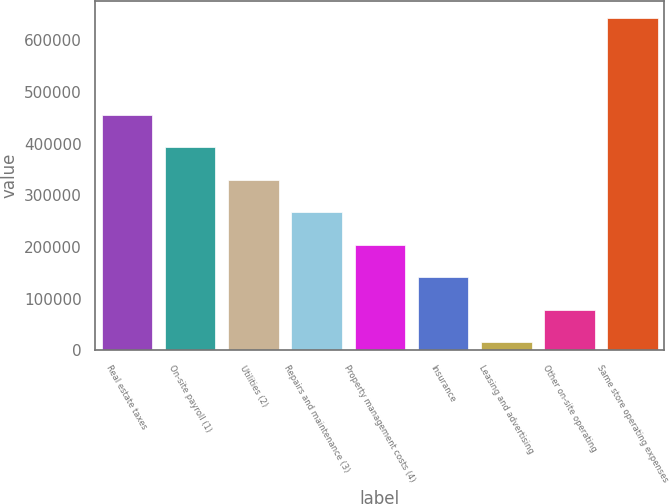Convert chart. <chart><loc_0><loc_0><loc_500><loc_500><bar_chart><fcel>Real estate taxes<fcel>On-site payroll (1)<fcel>Utilities (2)<fcel>Repairs and maintenance (3)<fcel>Property management costs (4)<fcel>Insurance<fcel>Leasing and advertising<fcel>Other on-site operating<fcel>Same store operating expenses<nl><fcel>455705<fcel>392842<fcel>329979<fcel>267116<fcel>204253<fcel>141390<fcel>15664<fcel>78527<fcel>644294<nl></chart> 